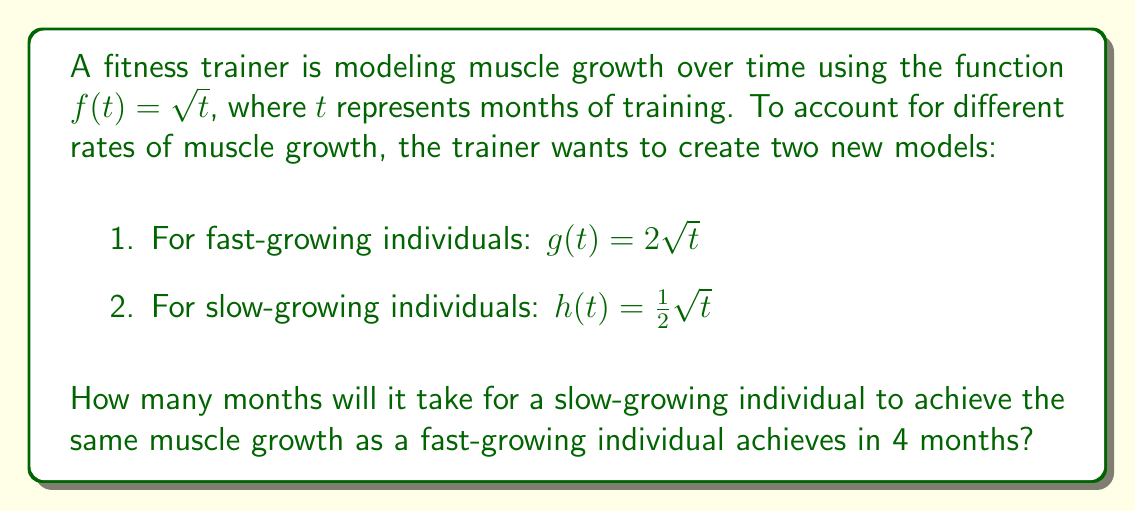Solve this math problem. Let's approach this step-by-step:

1) For the fast-growing individual after 4 months:
   $g(4) = 2\sqrt{4} = 2 \cdot 2 = 4$

2) We need to find $t$ for the slow-growing individual where:
   $h(t) = 4$

3) Let's set up the equation:
   $\frac{1}{2}\sqrt{t} = 4$

4) Multiply both sides by 2:
   $\sqrt{t} = 8$

5) Square both sides:
   $t = 64$

Therefore, it will take 64 months for a slow-growing individual to achieve the same muscle growth as a fast-growing individual achieves in 4 months.

This problem demonstrates vertical stretching and compression of the original function $f(t) = \sqrt{t}$. The function $g(t)$ is stretched vertically by a factor of 2, while $h(t)$ is compressed vertically by a factor of $\frac{1}{2}$.
Answer: 64 months 